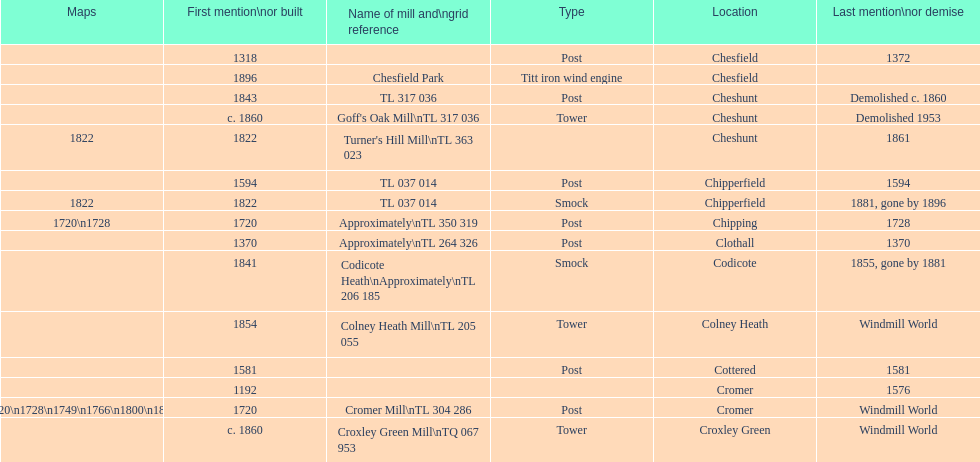How many mills were mentioned or built before 1700? 5. 